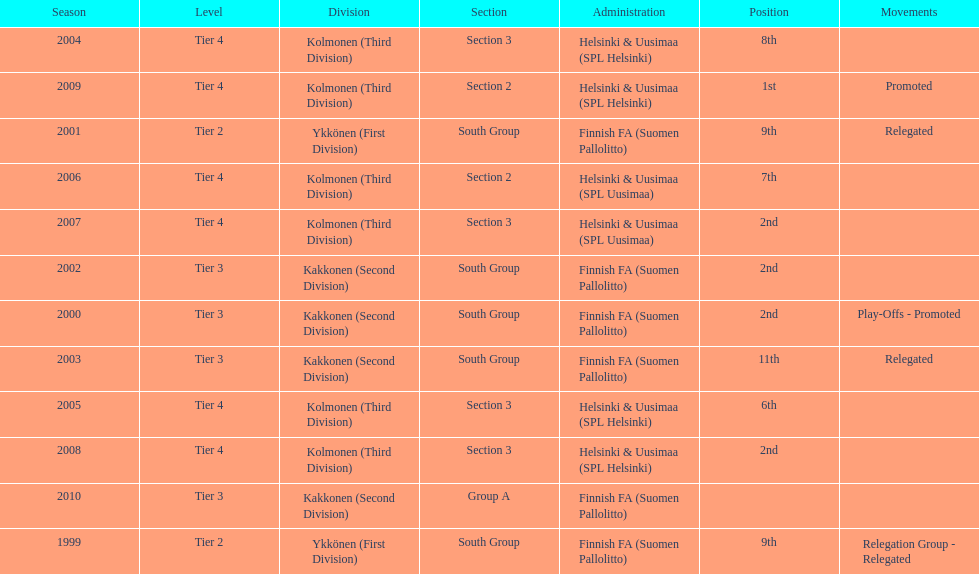How many tiers had more than one relegated movement? 1. 